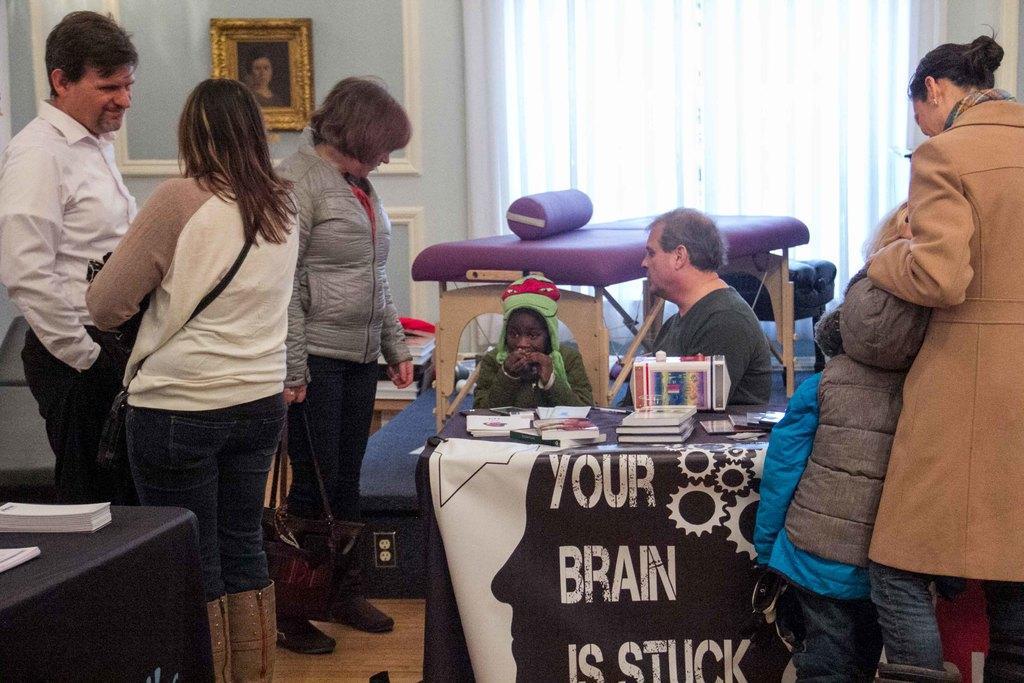Can you describe this image briefly? Few persons are standing. These two persons are sitting. We can see tables on the table there are books and things. On the background we can see wall,frame,curtain. 